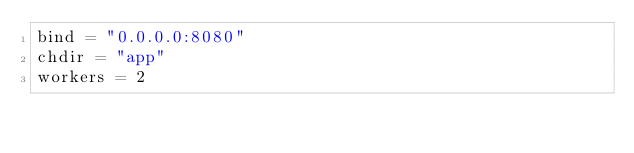<code> <loc_0><loc_0><loc_500><loc_500><_Python_>bind = "0.0.0.0:8080"
chdir = "app"
workers = 2
</code> 